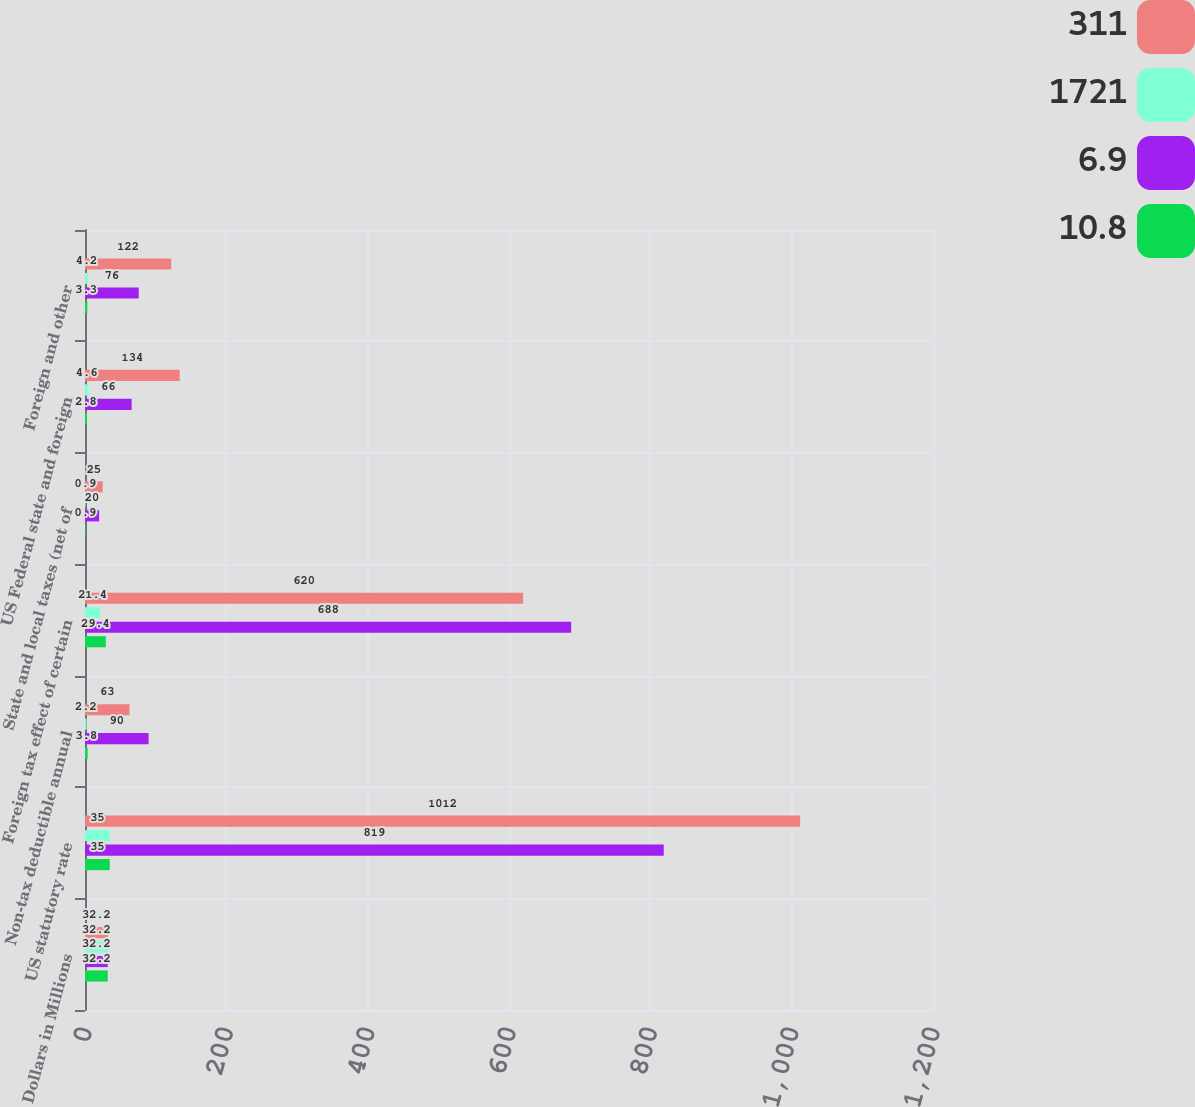Convert chart to OTSL. <chart><loc_0><loc_0><loc_500><loc_500><stacked_bar_chart><ecel><fcel>Dollars in Millions<fcel>US statutory rate<fcel>Non-tax deductible annual<fcel>Foreign tax effect of certain<fcel>State and local taxes (net of<fcel>US Federal state and foreign<fcel>Foreign and other<nl><fcel>311<fcel>32.2<fcel>1012<fcel>63<fcel>620<fcel>25<fcel>134<fcel>122<nl><fcel>1721<fcel>32.2<fcel>35<fcel>2.2<fcel>21.4<fcel>0.9<fcel>4.6<fcel>4.2<nl><fcel>6.9<fcel>32.2<fcel>819<fcel>90<fcel>688<fcel>20<fcel>66<fcel>76<nl><fcel>10.8<fcel>32.2<fcel>35<fcel>3.8<fcel>29.4<fcel>0.9<fcel>2.8<fcel>3.3<nl></chart> 